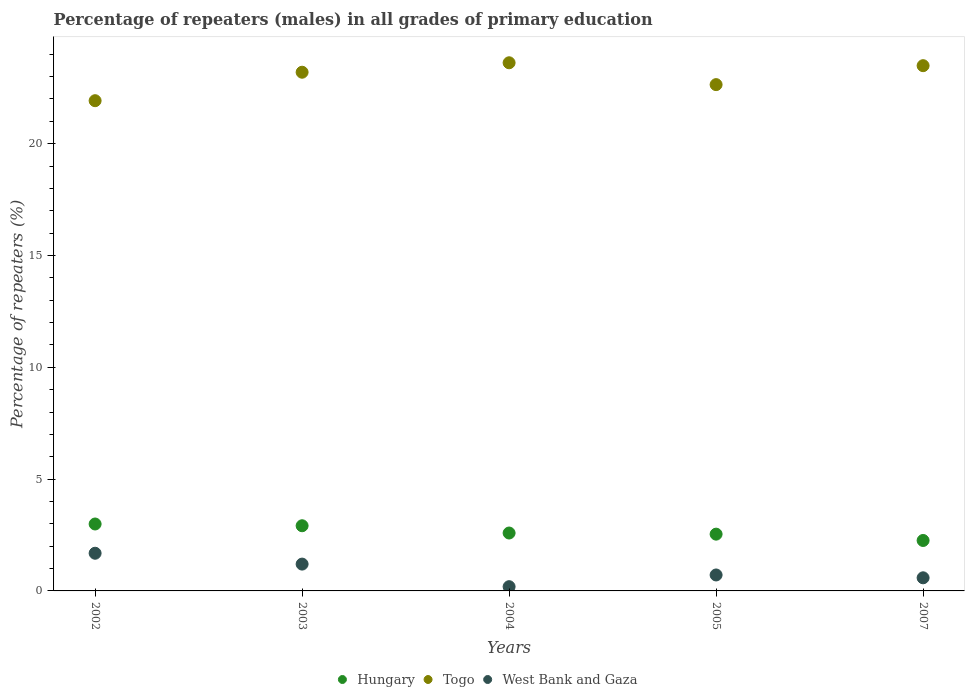How many different coloured dotlines are there?
Ensure brevity in your answer.  3. What is the percentage of repeaters (males) in Hungary in 2002?
Your response must be concise. 2.99. Across all years, what is the maximum percentage of repeaters (males) in Togo?
Offer a terse response. 23.62. Across all years, what is the minimum percentage of repeaters (males) in Hungary?
Your response must be concise. 2.26. What is the total percentage of repeaters (males) in West Bank and Gaza in the graph?
Keep it short and to the point. 4.37. What is the difference between the percentage of repeaters (males) in Togo in 2002 and that in 2003?
Your response must be concise. -1.27. What is the difference between the percentage of repeaters (males) in Hungary in 2004 and the percentage of repeaters (males) in West Bank and Gaza in 2005?
Your response must be concise. 1.88. What is the average percentage of repeaters (males) in West Bank and Gaza per year?
Give a very brief answer. 0.87. In the year 2005, what is the difference between the percentage of repeaters (males) in Togo and percentage of repeaters (males) in West Bank and Gaza?
Offer a terse response. 21.93. In how many years, is the percentage of repeaters (males) in Hungary greater than 10 %?
Your answer should be very brief. 0. What is the ratio of the percentage of repeaters (males) in Togo in 2002 to that in 2003?
Your answer should be compact. 0.95. What is the difference between the highest and the second highest percentage of repeaters (males) in Togo?
Offer a terse response. 0.13. What is the difference between the highest and the lowest percentage of repeaters (males) in Togo?
Your response must be concise. 1.7. Is the sum of the percentage of repeaters (males) in West Bank and Gaza in 2002 and 2007 greater than the maximum percentage of repeaters (males) in Hungary across all years?
Offer a terse response. No. Is the percentage of repeaters (males) in Togo strictly less than the percentage of repeaters (males) in West Bank and Gaza over the years?
Make the answer very short. No. What is the difference between two consecutive major ticks on the Y-axis?
Your response must be concise. 5. Are the values on the major ticks of Y-axis written in scientific E-notation?
Your response must be concise. No. Does the graph contain any zero values?
Ensure brevity in your answer.  No. Where does the legend appear in the graph?
Your answer should be very brief. Bottom center. What is the title of the graph?
Keep it short and to the point. Percentage of repeaters (males) in all grades of primary education. Does "Poland" appear as one of the legend labels in the graph?
Offer a very short reply. No. What is the label or title of the Y-axis?
Ensure brevity in your answer.  Percentage of repeaters (%). What is the Percentage of repeaters (%) of Hungary in 2002?
Your response must be concise. 2.99. What is the Percentage of repeaters (%) of Togo in 2002?
Give a very brief answer. 21.92. What is the Percentage of repeaters (%) of West Bank and Gaza in 2002?
Offer a very short reply. 1.68. What is the Percentage of repeaters (%) in Hungary in 2003?
Offer a terse response. 2.91. What is the Percentage of repeaters (%) in Togo in 2003?
Keep it short and to the point. 23.19. What is the Percentage of repeaters (%) of West Bank and Gaza in 2003?
Ensure brevity in your answer.  1.2. What is the Percentage of repeaters (%) in Hungary in 2004?
Your answer should be compact. 2.59. What is the Percentage of repeaters (%) in Togo in 2004?
Keep it short and to the point. 23.62. What is the Percentage of repeaters (%) in West Bank and Gaza in 2004?
Give a very brief answer. 0.19. What is the Percentage of repeaters (%) in Hungary in 2005?
Offer a terse response. 2.54. What is the Percentage of repeaters (%) of Togo in 2005?
Give a very brief answer. 22.64. What is the Percentage of repeaters (%) in West Bank and Gaza in 2005?
Make the answer very short. 0.71. What is the Percentage of repeaters (%) of Hungary in 2007?
Ensure brevity in your answer.  2.26. What is the Percentage of repeaters (%) of Togo in 2007?
Make the answer very short. 23.49. What is the Percentage of repeaters (%) of West Bank and Gaza in 2007?
Keep it short and to the point. 0.59. Across all years, what is the maximum Percentage of repeaters (%) in Hungary?
Provide a short and direct response. 2.99. Across all years, what is the maximum Percentage of repeaters (%) of Togo?
Offer a terse response. 23.62. Across all years, what is the maximum Percentage of repeaters (%) in West Bank and Gaza?
Provide a short and direct response. 1.68. Across all years, what is the minimum Percentage of repeaters (%) in Hungary?
Give a very brief answer. 2.26. Across all years, what is the minimum Percentage of repeaters (%) in Togo?
Offer a terse response. 21.92. Across all years, what is the minimum Percentage of repeaters (%) of West Bank and Gaza?
Your answer should be very brief. 0.19. What is the total Percentage of repeaters (%) in Hungary in the graph?
Your answer should be compact. 13.29. What is the total Percentage of repeaters (%) of Togo in the graph?
Provide a short and direct response. 114.86. What is the total Percentage of repeaters (%) in West Bank and Gaza in the graph?
Offer a very short reply. 4.37. What is the difference between the Percentage of repeaters (%) in Hungary in 2002 and that in 2003?
Make the answer very short. 0.08. What is the difference between the Percentage of repeaters (%) of Togo in 2002 and that in 2003?
Ensure brevity in your answer.  -1.27. What is the difference between the Percentage of repeaters (%) of West Bank and Gaza in 2002 and that in 2003?
Your answer should be very brief. 0.49. What is the difference between the Percentage of repeaters (%) in Hungary in 2002 and that in 2004?
Give a very brief answer. 0.4. What is the difference between the Percentage of repeaters (%) of Togo in 2002 and that in 2004?
Offer a terse response. -1.7. What is the difference between the Percentage of repeaters (%) of West Bank and Gaza in 2002 and that in 2004?
Make the answer very short. 1.5. What is the difference between the Percentage of repeaters (%) in Hungary in 2002 and that in 2005?
Offer a terse response. 0.45. What is the difference between the Percentage of repeaters (%) in Togo in 2002 and that in 2005?
Offer a very short reply. -0.72. What is the difference between the Percentage of repeaters (%) of West Bank and Gaza in 2002 and that in 2005?
Your answer should be compact. 0.97. What is the difference between the Percentage of repeaters (%) in Hungary in 2002 and that in 2007?
Make the answer very short. 0.74. What is the difference between the Percentage of repeaters (%) in Togo in 2002 and that in 2007?
Keep it short and to the point. -1.57. What is the difference between the Percentage of repeaters (%) in West Bank and Gaza in 2002 and that in 2007?
Provide a succinct answer. 1.1. What is the difference between the Percentage of repeaters (%) of Hungary in 2003 and that in 2004?
Your response must be concise. 0.33. What is the difference between the Percentage of repeaters (%) in Togo in 2003 and that in 2004?
Provide a succinct answer. -0.42. What is the difference between the Percentage of repeaters (%) in West Bank and Gaza in 2003 and that in 2004?
Keep it short and to the point. 1.01. What is the difference between the Percentage of repeaters (%) of Hungary in 2003 and that in 2005?
Keep it short and to the point. 0.38. What is the difference between the Percentage of repeaters (%) of Togo in 2003 and that in 2005?
Your answer should be compact. 0.55. What is the difference between the Percentage of repeaters (%) in West Bank and Gaza in 2003 and that in 2005?
Ensure brevity in your answer.  0.49. What is the difference between the Percentage of repeaters (%) of Hungary in 2003 and that in 2007?
Your response must be concise. 0.66. What is the difference between the Percentage of repeaters (%) in Togo in 2003 and that in 2007?
Your answer should be very brief. -0.29. What is the difference between the Percentage of repeaters (%) of West Bank and Gaza in 2003 and that in 2007?
Ensure brevity in your answer.  0.61. What is the difference between the Percentage of repeaters (%) in Hungary in 2004 and that in 2005?
Provide a succinct answer. 0.05. What is the difference between the Percentage of repeaters (%) of Togo in 2004 and that in 2005?
Make the answer very short. 0.98. What is the difference between the Percentage of repeaters (%) of West Bank and Gaza in 2004 and that in 2005?
Provide a short and direct response. -0.52. What is the difference between the Percentage of repeaters (%) of Hungary in 2004 and that in 2007?
Your answer should be compact. 0.33. What is the difference between the Percentage of repeaters (%) of Togo in 2004 and that in 2007?
Your response must be concise. 0.13. What is the difference between the Percentage of repeaters (%) of West Bank and Gaza in 2004 and that in 2007?
Provide a succinct answer. -0.4. What is the difference between the Percentage of repeaters (%) in Hungary in 2005 and that in 2007?
Your answer should be compact. 0.28. What is the difference between the Percentage of repeaters (%) of Togo in 2005 and that in 2007?
Offer a terse response. -0.85. What is the difference between the Percentage of repeaters (%) in West Bank and Gaza in 2005 and that in 2007?
Your answer should be compact. 0.13. What is the difference between the Percentage of repeaters (%) in Hungary in 2002 and the Percentage of repeaters (%) in Togo in 2003?
Keep it short and to the point. -20.2. What is the difference between the Percentage of repeaters (%) of Hungary in 2002 and the Percentage of repeaters (%) of West Bank and Gaza in 2003?
Give a very brief answer. 1.79. What is the difference between the Percentage of repeaters (%) of Togo in 2002 and the Percentage of repeaters (%) of West Bank and Gaza in 2003?
Offer a very short reply. 20.72. What is the difference between the Percentage of repeaters (%) of Hungary in 2002 and the Percentage of repeaters (%) of Togo in 2004?
Ensure brevity in your answer.  -20.62. What is the difference between the Percentage of repeaters (%) of Hungary in 2002 and the Percentage of repeaters (%) of West Bank and Gaza in 2004?
Make the answer very short. 2.8. What is the difference between the Percentage of repeaters (%) in Togo in 2002 and the Percentage of repeaters (%) in West Bank and Gaza in 2004?
Your answer should be very brief. 21.73. What is the difference between the Percentage of repeaters (%) in Hungary in 2002 and the Percentage of repeaters (%) in Togo in 2005?
Make the answer very short. -19.65. What is the difference between the Percentage of repeaters (%) of Hungary in 2002 and the Percentage of repeaters (%) of West Bank and Gaza in 2005?
Your answer should be compact. 2.28. What is the difference between the Percentage of repeaters (%) of Togo in 2002 and the Percentage of repeaters (%) of West Bank and Gaza in 2005?
Your response must be concise. 21.21. What is the difference between the Percentage of repeaters (%) in Hungary in 2002 and the Percentage of repeaters (%) in Togo in 2007?
Your answer should be very brief. -20.49. What is the difference between the Percentage of repeaters (%) of Hungary in 2002 and the Percentage of repeaters (%) of West Bank and Gaza in 2007?
Your response must be concise. 2.41. What is the difference between the Percentage of repeaters (%) of Togo in 2002 and the Percentage of repeaters (%) of West Bank and Gaza in 2007?
Offer a very short reply. 21.33. What is the difference between the Percentage of repeaters (%) in Hungary in 2003 and the Percentage of repeaters (%) in Togo in 2004?
Keep it short and to the point. -20.7. What is the difference between the Percentage of repeaters (%) in Hungary in 2003 and the Percentage of repeaters (%) in West Bank and Gaza in 2004?
Your response must be concise. 2.72. What is the difference between the Percentage of repeaters (%) in Togo in 2003 and the Percentage of repeaters (%) in West Bank and Gaza in 2004?
Give a very brief answer. 23. What is the difference between the Percentage of repeaters (%) of Hungary in 2003 and the Percentage of repeaters (%) of Togo in 2005?
Make the answer very short. -19.73. What is the difference between the Percentage of repeaters (%) in Hungary in 2003 and the Percentage of repeaters (%) in West Bank and Gaza in 2005?
Your answer should be compact. 2.2. What is the difference between the Percentage of repeaters (%) in Togo in 2003 and the Percentage of repeaters (%) in West Bank and Gaza in 2005?
Your answer should be compact. 22.48. What is the difference between the Percentage of repeaters (%) of Hungary in 2003 and the Percentage of repeaters (%) of Togo in 2007?
Your response must be concise. -20.57. What is the difference between the Percentage of repeaters (%) of Hungary in 2003 and the Percentage of repeaters (%) of West Bank and Gaza in 2007?
Your answer should be compact. 2.33. What is the difference between the Percentage of repeaters (%) of Togo in 2003 and the Percentage of repeaters (%) of West Bank and Gaza in 2007?
Make the answer very short. 22.61. What is the difference between the Percentage of repeaters (%) of Hungary in 2004 and the Percentage of repeaters (%) of Togo in 2005?
Give a very brief answer. -20.05. What is the difference between the Percentage of repeaters (%) in Hungary in 2004 and the Percentage of repeaters (%) in West Bank and Gaza in 2005?
Provide a succinct answer. 1.88. What is the difference between the Percentage of repeaters (%) in Togo in 2004 and the Percentage of repeaters (%) in West Bank and Gaza in 2005?
Your response must be concise. 22.9. What is the difference between the Percentage of repeaters (%) in Hungary in 2004 and the Percentage of repeaters (%) in Togo in 2007?
Your answer should be very brief. -20.9. What is the difference between the Percentage of repeaters (%) of Hungary in 2004 and the Percentage of repeaters (%) of West Bank and Gaza in 2007?
Provide a succinct answer. 2. What is the difference between the Percentage of repeaters (%) in Togo in 2004 and the Percentage of repeaters (%) in West Bank and Gaza in 2007?
Provide a succinct answer. 23.03. What is the difference between the Percentage of repeaters (%) in Hungary in 2005 and the Percentage of repeaters (%) in Togo in 2007?
Give a very brief answer. -20.95. What is the difference between the Percentage of repeaters (%) in Hungary in 2005 and the Percentage of repeaters (%) in West Bank and Gaza in 2007?
Provide a short and direct response. 1.95. What is the difference between the Percentage of repeaters (%) in Togo in 2005 and the Percentage of repeaters (%) in West Bank and Gaza in 2007?
Make the answer very short. 22.05. What is the average Percentage of repeaters (%) in Hungary per year?
Provide a succinct answer. 2.66. What is the average Percentage of repeaters (%) in Togo per year?
Your answer should be very brief. 22.97. What is the average Percentage of repeaters (%) in West Bank and Gaza per year?
Your answer should be compact. 0.87. In the year 2002, what is the difference between the Percentage of repeaters (%) in Hungary and Percentage of repeaters (%) in Togo?
Make the answer very short. -18.93. In the year 2002, what is the difference between the Percentage of repeaters (%) of Hungary and Percentage of repeaters (%) of West Bank and Gaza?
Offer a terse response. 1.31. In the year 2002, what is the difference between the Percentage of repeaters (%) of Togo and Percentage of repeaters (%) of West Bank and Gaza?
Keep it short and to the point. 20.24. In the year 2003, what is the difference between the Percentage of repeaters (%) in Hungary and Percentage of repeaters (%) in Togo?
Give a very brief answer. -20.28. In the year 2003, what is the difference between the Percentage of repeaters (%) in Hungary and Percentage of repeaters (%) in West Bank and Gaza?
Offer a terse response. 1.71. In the year 2003, what is the difference between the Percentage of repeaters (%) of Togo and Percentage of repeaters (%) of West Bank and Gaza?
Your response must be concise. 21.99. In the year 2004, what is the difference between the Percentage of repeaters (%) in Hungary and Percentage of repeaters (%) in Togo?
Your answer should be very brief. -21.03. In the year 2004, what is the difference between the Percentage of repeaters (%) in Hungary and Percentage of repeaters (%) in West Bank and Gaza?
Make the answer very short. 2.4. In the year 2004, what is the difference between the Percentage of repeaters (%) in Togo and Percentage of repeaters (%) in West Bank and Gaza?
Your answer should be very brief. 23.43. In the year 2005, what is the difference between the Percentage of repeaters (%) in Hungary and Percentage of repeaters (%) in Togo?
Offer a terse response. -20.1. In the year 2005, what is the difference between the Percentage of repeaters (%) in Hungary and Percentage of repeaters (%) in West Bank and Gaza?
Give a very brief answer. 1.83. In the year 2005, what is the difference between the Percentage of repeaters (%) in Togo and Percentage of repeaters (%) in West Bank and Gaza?
Provide a short and direct response. 21.93. In the year 2007, what is the difference between the Percentage of repeaters (%) of Hungary and Percentage of repeaters (%) of Togo?
Make the answer very short. -21.23. In the year 2007, what is the difference between the Percentage of repeaters (%) in Hungary and Percentage of repeaters (%) in West Bank and Gaza?
Ensure brevity in your answer.  1.67. In the year 2007, what is the difference between the Percentage of repeaters (%) of Togo and Percentage of repeaters (%) of West Bank and Gaza?
Provide a succinct answer. 22.9. What is the ratio of the Percentage of repeaters (%) of Hungary in 2002 to that in 2003?
Provide a succinct answer. 1.03. What is the ratio of the Percentage of repeaters (%) in Togo in 2002 to that in 2003?
Offer a very short reply. 0.95. What is the ratio of the Percentage of repeaters (%) in West Bank and Gaza in 2002 to that in 2003?
Your response must be concise. 1.4. What is the ratio of the Percentage of repeaters (%) of Hungary in 2002 to that in 2004?
Keep it short and to the point. 1.16. What is the ratio of the Percentage of repeaters (%) of Togo in 2002 to that in 2004?
Provide a succinct answer. 0.93. What is the ratio of the Percentage of repeaters (%) in West Bank and Gaza in 2002 to that in 2004?
Your answer should be compact. 8.87. What is the ratio of the Percentage of repeaters (%) of Hungary in 2002 to that in 2005?
Ensure brevity in your answer.  1.18. What is the ratio of the Percentage of repeaters (%) of Togo in 2002 to that in 2005?
Your answer should be very brief. 0.97. What is the ratio of the Percentage of repeaters (%) in West Bank and Gaza in 2002 to that in 2005?
Your response must be concise. 2.36. What is the ratio of the Percentage of repeaters (%) of Hungary in 2002 to that in 2007?
Offer a very short reply. 1.33. What is the ratio of the Percentage of repeaters (%) of Togo in 2002 to that in 2007?
Give a very brief answer. 0.93. What is the ratio of the Percentage of repeaters (%) in West Bank and Gaza in 2002 to that in 2007?
Provide a succinct answer. 2.87. What is the ratio of the Percentage of repeaters (%) in Hungary in 2003 to that in 2004?
Keep it short and to the point. 1.13. What is the ratio of the Percentage of repeaters (%) in Togo in 2003 to that in 2004?
Offer a very short reply. 0.98. What is the ratio of the Percentage of repeaters (%) of West Bank and Gaza in 2003 to that in 2004?
Ensure brevity in your answer.  6.32. What is the ratio of the Percentage of repeaters (%) in Hungary in 2003 to that in 2005?
Ensure brevity in your answer.  1.15. What is the ratio of the Percentage of repeaters (%) of Togo in 2003 to that in 2005?
Keep it short and to the point. 1.02. What is the ratio of the Percentage of repeaters (%) in West Bank and Gaza in 2003 to that in 2005?
Provide a short and direct response. 1.68. What is the ratio of the Percentage of repeaters (%) of Hungary in 2003 to that in 2007?
Ensure brevity in your answer.  1.29. What is the ratio of the Percentage of repeaters (%) in Togo in 2003 to that in 2007?
Give a very brief answer. 0.99. What is the ratio of the Percentage of repeaters (%) in West Bank and Gaza in 2003 to that in 2007?
Offer a very short reply. 2.05. What is the ratio of the Percentage of repeaters (%) in Hungary in 2004 to that in 2005?
Keep it short and to the point. 1.02. What is the ratio of the Percentage of repeaters (%) of Togo in 2004 to that in 2005?
Provide a succinct answer. 1.04. What is the ratio of the Percentage of repeaters (%) in West Bank and Gaza in 2004 to that in 2005?
Provide a short and direct response. 0.27. What is the ratio of the Percentage of repeaters (%) of Hungary in 2004 to that in 2007?
Keep it short and to the point. 1.15. What is the ratio of the Percentage of repeaters (%) in Togo in 2004 to that in 2007?
Make the answer very short. 1.01. What is the ratio of the Percentage of repeaters (%) of West Bank and Gaza in 2004 to that in 2007?
Provide a succinct answer. 0.32. What is the ratio of the Percentage of repeaters (%) of Hungary in 2005 to that in 2007?
Your answer should be very brief. 1.13. What is the ratio of the Percentage of repeaters (%) in Togo in 2005 to that in 2007?
Keep it short and to the point. 0.96. What is the ratio of the Percentage of repeaters (%) of West Bank and Gaza in 2005 to that in 2007?
Make the answer very short. 1.22. What is the difference between the highest and the second highest Percentage of repeaters (%) of Hungary?
Offer a terse response. 0.08. What is the difference between the highest and the second highest Percentage of repeaters (%) in Togo?
Your answer should be very brief. 0.13. What is the difference between the highest and the second highest Percentage of repeaters (%) of West Bank and Gaza?
Offer a very short reply. 0.49. What is the difference between the highest and the lowest Percentage of repeaters (%) in Hungary?
Give a very brief answer. 0.74. What is the difference between the highest and the lowest Percentage of repeaters (%) of Togo?
Offer a very short reply. 1.7. What is the difference between the highest and the lowest Percentage of repeaters (%) in West Bank and Gaza?
Ensure brevity in your answer.  1.5. 